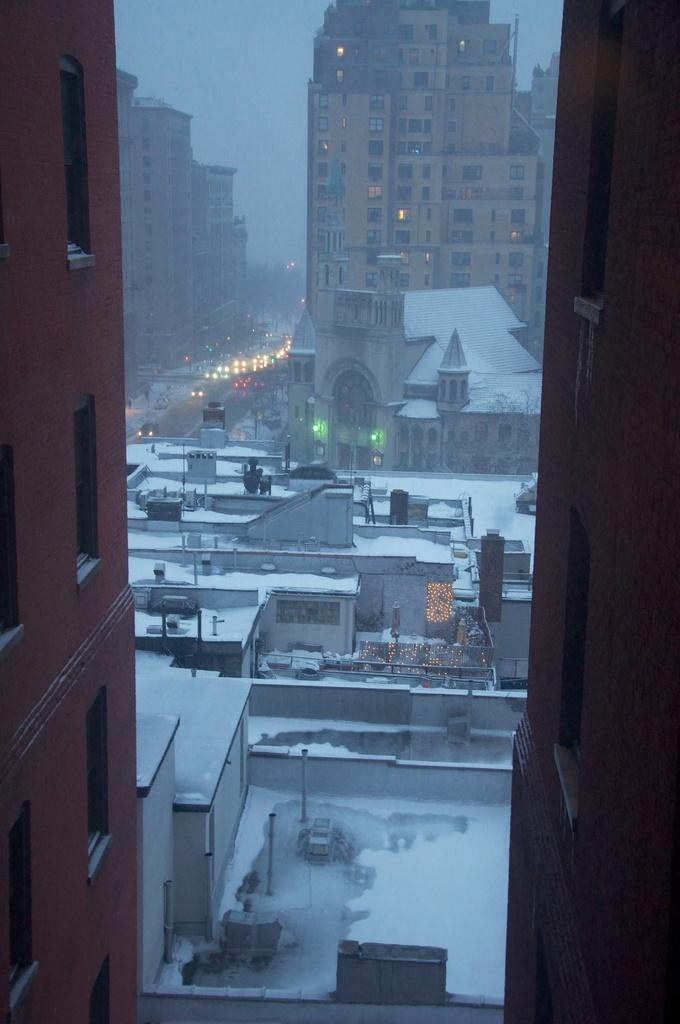What structures are visible in the image? There are buildings in the image. How is the appearance of the buildings affected in the image? The buildings are covered with snow. What else can be seen on the ground in the image? There are vehicles on the road in the image. Where is the dock located in the image? There is no dock present in the image. What type of breakfast is being served in the image? There is no breakfast present in the image. 